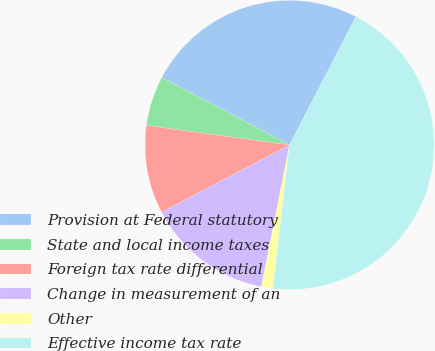<chart> <loc_0><loc_0><loc_500><loc_500><pie_chart><fcel>Provision at Federal statutory<fcel>State and local income taxes<fcel>Foreign tax rate differential<fcel>Change in measurement of an<fcel>Other<fcel>Effective income tax rate<nl><fcel>24.86%<fcel>5.58%<fcel>9.87%<fcel>14.17%<fcel>1.28%<fcel>44.25%<nl></chart> 